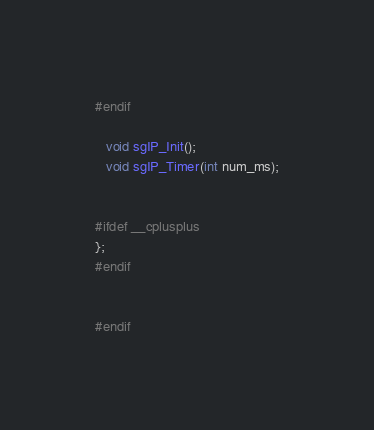Convert code to text. <code><loc_0><loc_0><loc_500><loc_500><_C_>#endif

   void sgIP_Init();
   void sgIP_Timer(int num_ms);


#ifdef __cplusplus
};
#endif


#endif
</code> 